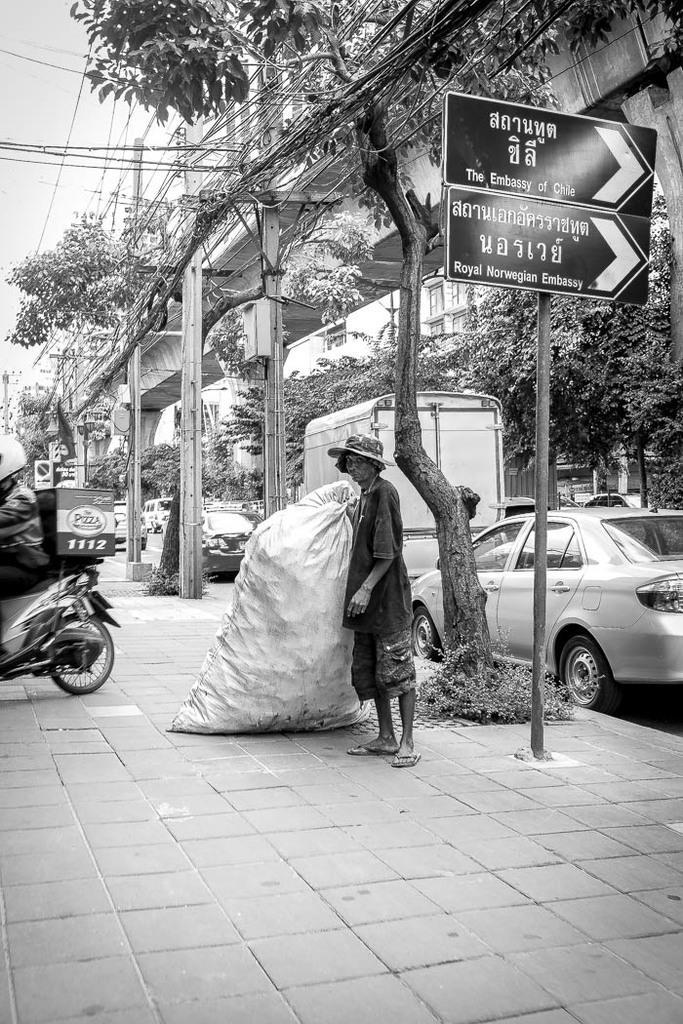In one or two sentences, can you explain what this image depicts? In this image I can see the black and white picture in which I can see the sidewalk, a person standing on the sidewalk holding a huge bag, a person riding a motor bike, few trees, a pole with two boards attached to it, a bridge, few vehicles on the road and few electric poles. In the background I can see few buildings, few trees, few wires and the sky. 